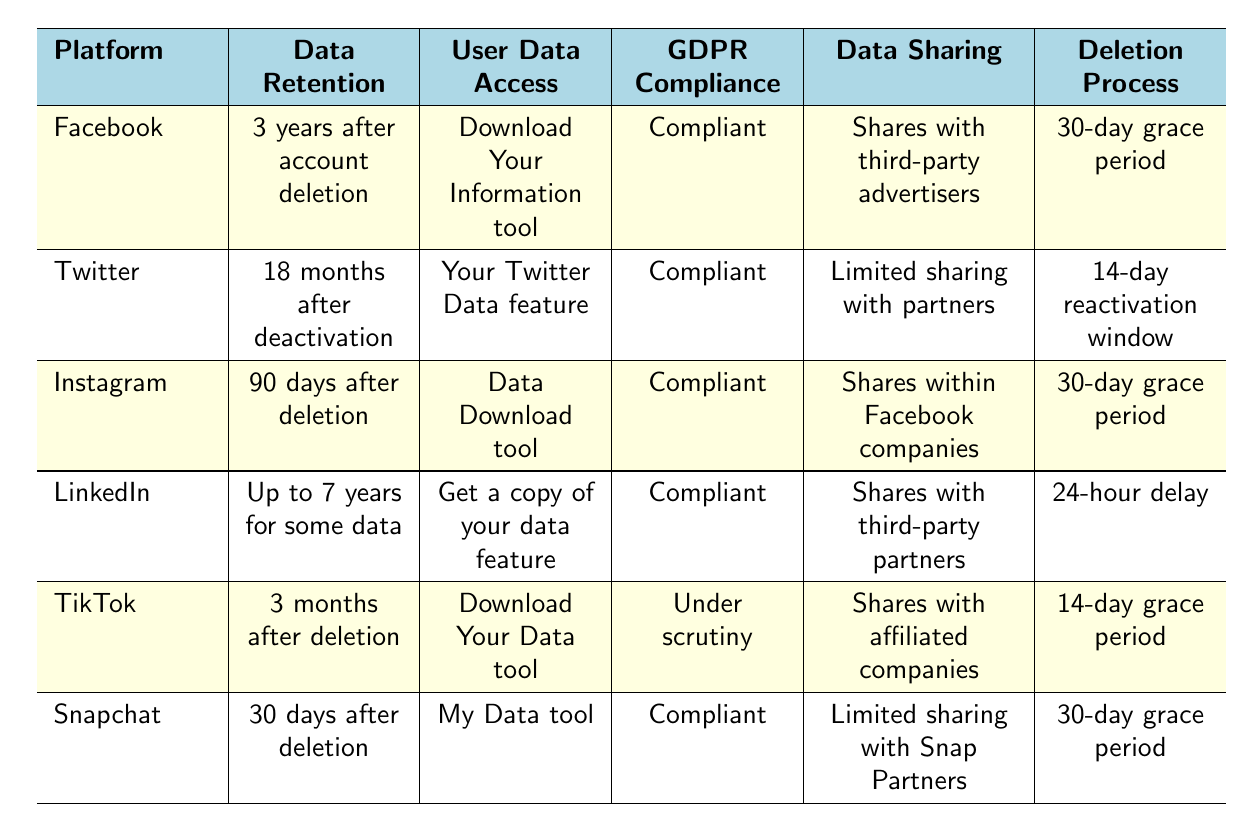What is the data retention period for Instagram? According to the table, Instagram retains data for 90 days after account deletion.
Answer: 90 days after deletion Which platforms allow user data access through a tool? The table lists Facebook (Download Your Information tool), Twitter (Your Twitter Data feature), Instagram (Data Download tool), LinkedIn (Get a copy of your data feature), TikTok (Download Your Data tool), and Snapchat (My Data tool) as platforms that offer user data access through specific tools.
Answer: All listed platforms How long does TikTok retain user data after account deletion? TikTok has a data retention period of 3 months after account deletion as stated in the table.
Answer: 3 months Is Snapchat compliant with GDPR regulations? Yes, according to the table, Snapchat is labeled as compliant with GDPR regulations.
Answer: Yes Which platform has the longest data retention period? LinkedIn is noted for having a variable data retention period of up to 7 years for some types of user data, which is longer than the other platforms listed.
Answer: Up to 7 years What is the average data retention period for the platforms listed? To find the average, we convert retention periods into months: Facebook (36), Twitter (18), Instagram (3), LinkedIn (assume average 7 years = 84), TikTok (3), and Snapchat (1). The total is 36 + 18 + 3 + 84 + 3 + 1 = 145 months. There are 6 platforms, so the average is 145 / 6 = 24.17 months.
Answer: 24.17 months Do any platforms share data with third-party advertisers? Yes, Facebook shares data with third-party advertisers, as indicated in the data sharing practices column in the table.
Answer: Yes What is the deletion process for Twitter? Twitter has a 14-day reactivation window before permanent deletion, as mentioned in the deletion process column of the table.
Answer: 14-day reactivation window How does the data sharing practice of LinkedIn compare to that of Instagram? LinkedIn shares data with third-party partners, while Instagram shares data within the Facebook family of companies; both practices involve sharing data but with different groups.
Answer: Different sharing groups 